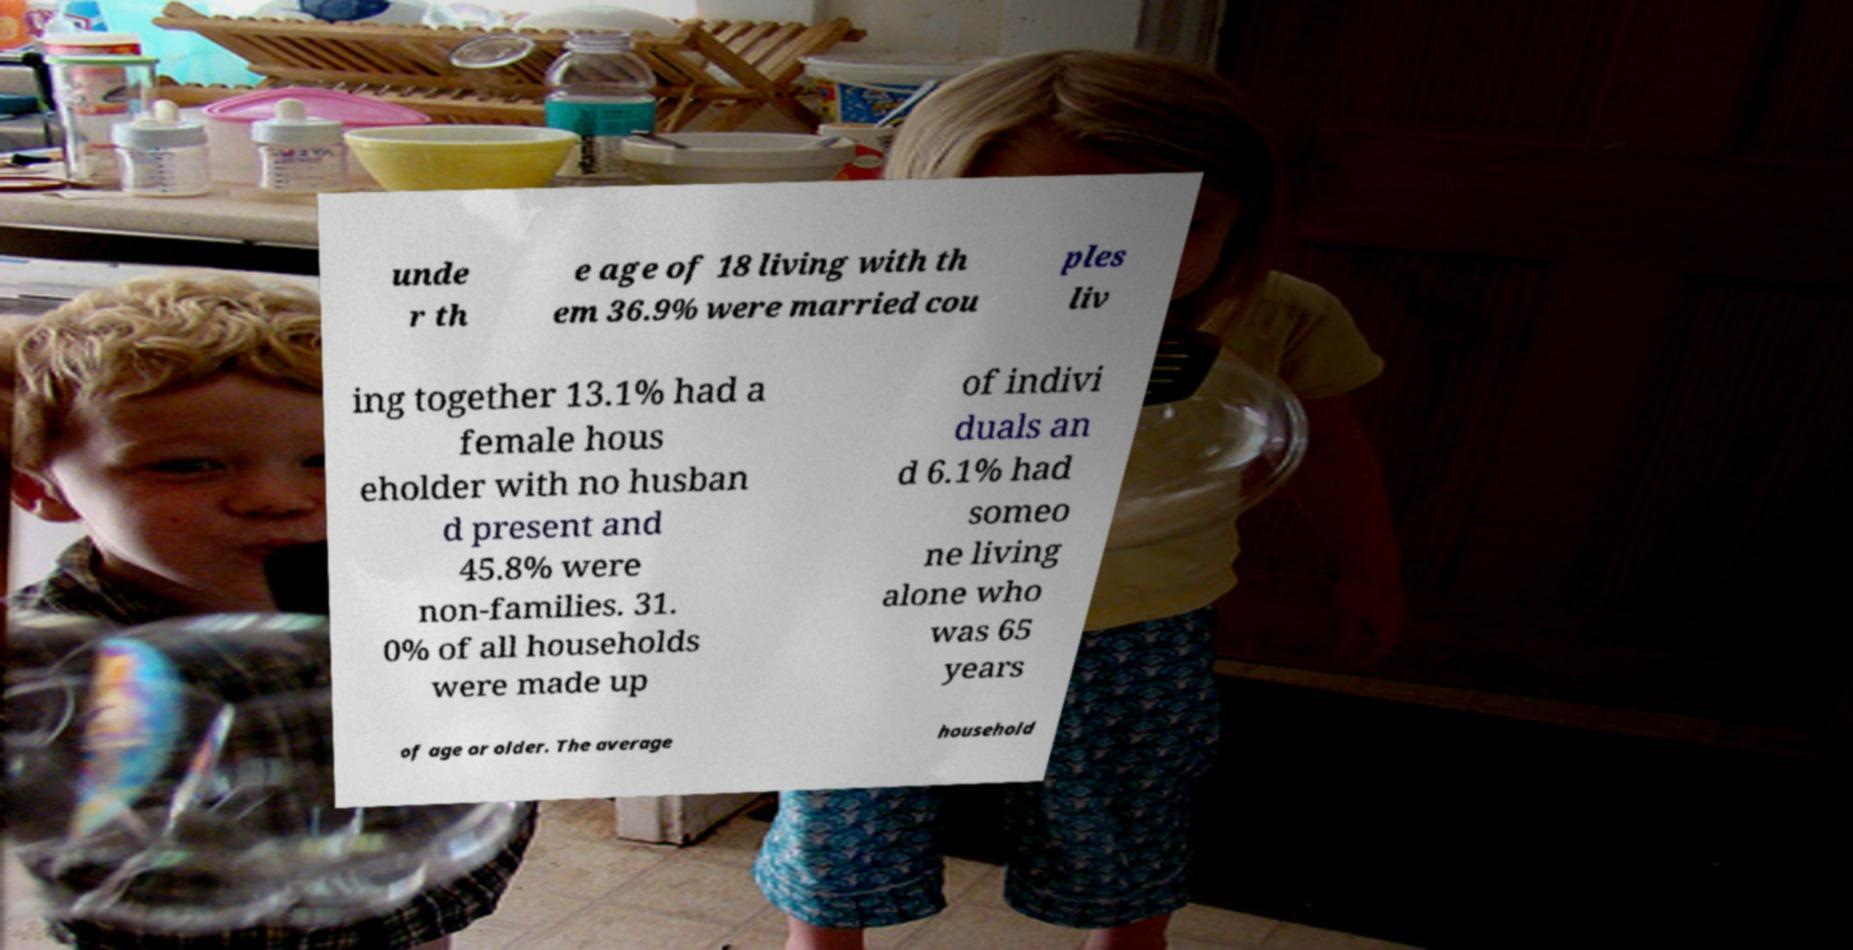Please read and relay the text visible in this image. What does it say? unde r th e age of 18 living with th em 36.9% were married cou ples liv ing together 13.1% had a female hous eholder with no husban d present and 45.8% were non-families. 31. 0% of all households were made up of indivi duals an d 6.1% had someo ne living alone who was 65 years of age or older. The average household 